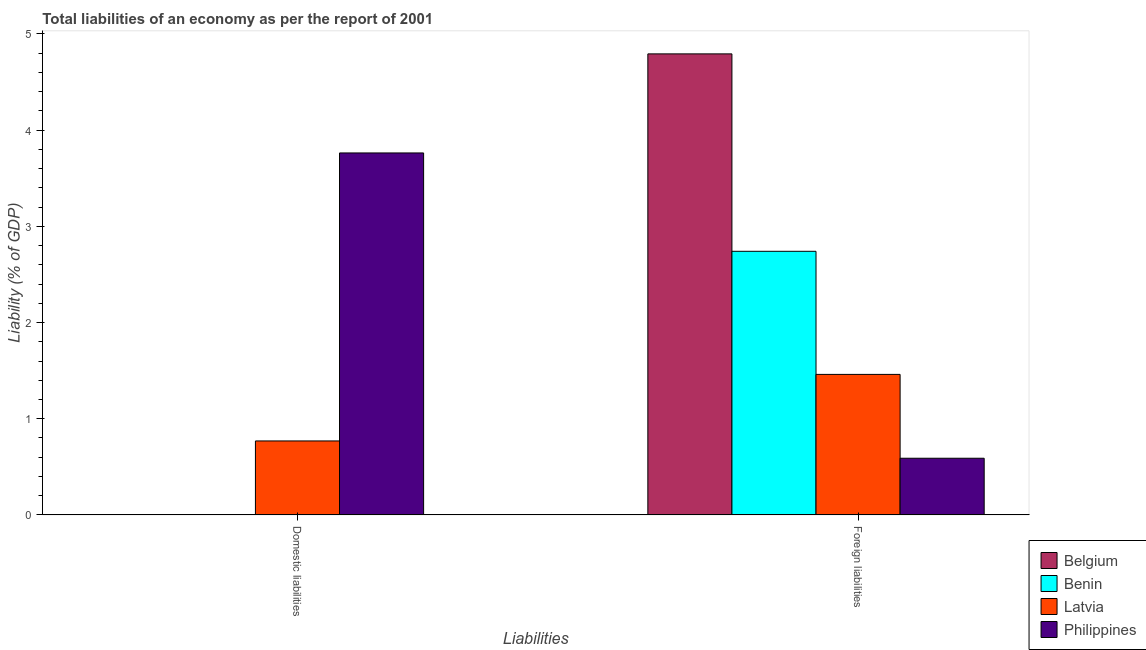How many different coloured bars are there?
Offer a terse response. 4. Are the number of bars per tick equal to the number of legend labels?
Your response must be concise. No. How many bars are there on the 1st tick from the left?
Your answer should be very brief. 2. How many bars are there on the 2nd tick from the right?
Your response must be concise. 2. What is the label of the 1st group of bars from the left?
Provide a succinct answer. Domestic liabilities. What is the incurrence of domestic liabilities in Latvia?
Make the answer very short. 0.77. Across all countries, what is the maximum incurrence of domestic liabilities?
Ensure brevity in your answer.  3.76. Across all countries, what is the minimum incurrence of foreign liabilities?
Ensure brevity in your answer.  0.59. What is the total incurrence of domestic liabilities in the graph?
Keep it short and to the point. 4.53. What is the difference between the incurrence of foreign liabilities in Benin and that in Philippines?
Make the answer very short. 2.15. What is the difference between the incurrence of foreign liabilities in Latvia and the incurrence of domestic liabilities in Belgium?
Provide a short and direct response. 1.46. What is the average incurrence of domestic liabilities per country?
Ensure brevity in your answer.  1.13. What is the difference between the incurrence of foreign liabilities and incurrence of domestic liabilities in Latvia?
Offer a very short reply. 0.69. What is the ratio of the incurrence of foreign liabilities in Belgium to that in Philippines?
Your answer should be compact. 8.13. In how many countries, is the incurrence of domestic liabilities greater than the average incurrence of domestic liabilities taken over all countries?
Your answer should be very brief. 1. How many countries are there in the graph?
Your answer should be very brief. 4. Does the graph contain grids?
Provide a succinct answer. No. Where does the legend appear in the graph?
Provide a succinct answer. Bottom right. How are the legend labels stacked?
Provide a short and direct response. Vertical. What is the title of the graph?
Provide a succinct answer. Total liabilities of an economy as per the report of 2001. Does "Jordan" appear as one of the legend labels in the graph?
Your answer should be compact. No. What is the label or title of the X-axis?
Keep it short and to the point. Liabilities. What is the label or title of the Y-axis?
Keep it short and to the point. Liability (% of GDP). What is the Liability (% of GDP) of Latvia in Domestic liabilities?
Your response must be concise. 0.77. What is the Liability (% of GDP) of Philippines in Domestic liabilities?
Make the answer very short. 3.76. What is the Liability (% of GDP) of Belgium in Foreign liabilities?
Offer a very short reply. 4.79. What is the Liability (% of GDP) of Benin in Foreign liabilities?
Give a very brief answer. 2.74. What is the Liability (% of GDP) of Latvia in Foreign liabilities?
Your response must be concise. 1.46. What is the Liability (% of GDP) of Philippines in Foreign liabilities?
Your response must be concise. 0.59. Across all Liabilities, what is the maximum Liability (% of GDP) of Belgium?
Provide a short and direct response. 4.79. Across all Liabilities, what is the maximum Liability (% of GDP) of Benin?
Offer a terse response. 2.74. Across all Liabilities, what is the maximum Liability (% of GDP) in Latvia?
Make the answer very short. 1.46. Across all Liabilities, what is the maximum Liability (% of GDP) of Philippines?
Provide a short and direct response. 3.76. Across all Liabilities, what is the minimum Liability (% of GDP) in Belgium?
Provide a succinct answer. 0. Across all Liabilities, what is the minimum Liability (% of GDP) of Benin?
Provide a short and direct response. 0. Across all Liabilities, what is the minimum Liability (% of GDP) of Latvia?
Your answer should be compact. 0.77. Across all Liabilities, what is the minimum Liability (% of GDP) of Philippines?
Make the answer very short. 0.59. What is the total Liability (% of GDP) in Belgium in the graph?
Offer a terse response. 4.79. What is the total Liability (% of GDP) in Benin in the graph?
Your response must be concise. 2.74. What is the total Liability (% of GDP) in Latvia in the graph?
Ensure brevity in your answer.  2.23. What is the total Liability (% of GDP) of Philippines in the graph?
Make the answer very short. 4.35. What is the difference between the Liability (% of GDP) in Latvia in Domestic liabilities and that in Foreign liabilities?
Provide a succinct answer. -0.69. What is the difference between the Liability (% of GDP) of Philippines in Domestic liabilities and that in Foreign liabilities?
Make the answer very short. 3.17. What is the difference between the Liability (% of GDP) of Latvia in Domestic liabilities and the Liability (% of GDP) of Philippines in Foreign liabilities?
Ensure brevity in your answer.  0.18. What is the average Liability (% of GDP) in Belgium per Liabilities?
Offer a terse response. 2.4. What is the average Liability (% of GDP) in Benin per Liabilities?
Offer a terse response. 1.37. What is the average Liability (% of GDP) of Latvia per Liabilities?
Offer a very short reply. 1.11. What is the average Liability (% of GDP) in Philippines per Liabilities?
Your answer should be compact. 2.18. What is the difference between the Liability (% of GDP) of Latvia and Liability (% of GDP) of Philippines in Domestic liabilities?
Your answer should be very brief. -2.99. What is the difference between the Liability (% of GDP) in Belgium and Liability (% of GDP) in Benin in Foreign liabilities?
Your response must be concise. 2.05. What is the difference between the Liability (% of GDP) of Belgium and Liability (% of GDP) of Latvia in Foreign liabilities?
Offer a very short reply. 3.33. What is the difference between the Liability (% of GDP) of Belgium and Liability (% of GDP) of Philippines in Foreign liabilities?
Give a very brief answer. 4.2. What is the difference between the Liability (% of GDP) in Benin and Liability (% of GDP) in Latvia in Foreign liabilities?
Provide a short and direct response. 1.28. What is the difference between the Liability (% of GDP) of Benin and Liability (% of GDP) of Philippines in Foreign liabilities?
Offer a very short reply. 2.15. What is the difference between the Liability (% of GDP) in Latvia and Liability (% of GDP) in Philippines in Foreign liabilities?
Provide a short and direct response. 0.87. What is the ratio of the Liability (% of GDP) in Latvia in Domestic liabilities to that in Foreign liabilities?
Make the answer very short. 0.53. What is the ratio of the Liability (% of GDP) in Philippines in Domestic liabilities to that in Foreign liabilities?
Provide a succinct answer. 6.39. What is the difference between the highest and the second highest Liability (% of GDP) of Latvia?
Your answer should be very brief. 0.69. What is the difference between the highest and the second highest Liability (% of GDP) in Philippines?
Ensure brevity in your answer.  3.17. What is the difference between the highest and the lowest Liability (% of GDP) in Belgium?
Provide a succinct answer. 4.79. What is the difference between the highest and the lowest Liability (% of GDP) of Benin?
Your answer should be compact. 2.74. What is the difference between the highest and the lowest Liability (% of GDP) in Latvia?
Ensure brevity in your answer.  0.69. What is the difference between the highest and the lowest Liability (% of GDP) in Philippines?
Make the answer very short. 3.17. 